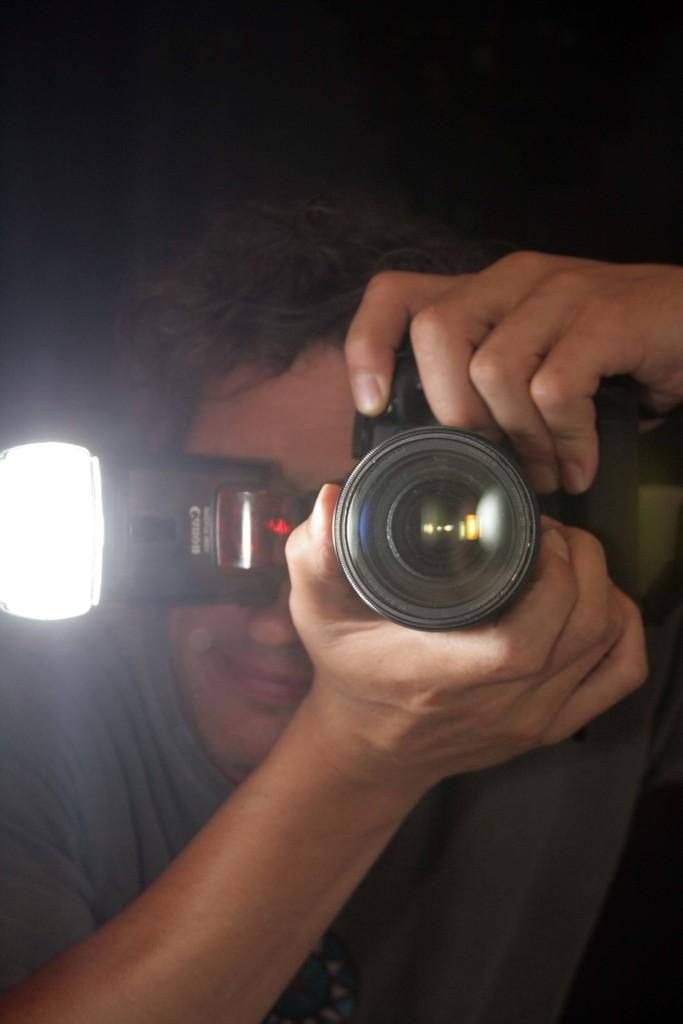What is the main subject of the image? There is a person in the image. What is the person holding in the image? The person is holding a camera. What is the person doing with the camera? The person is clicking a picture. What type of government is depicted in the image? There is no depiction of a government in the image; it features a person holding a camera and clicking a picture. 